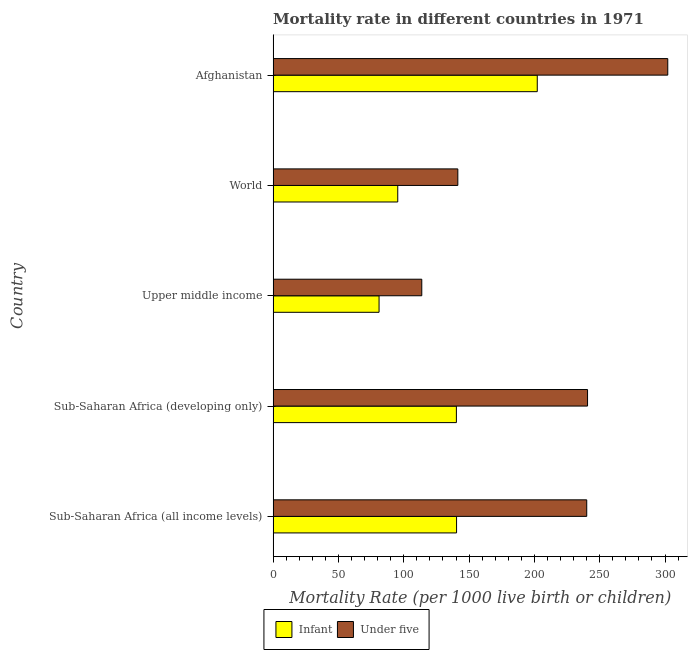How many different coloured bars are there?
Your answer should be very brief. 2. Are the number of bars per tick equal to the number of legend labels?
Your response must be concise. Yes. Are the number of bars on each tick of the Y-axis equal?
Your answer should be compact. Yes. How many bars are there on the 3rd tick from the top?
Keep it short and to the point. 2. How many bars are there on the 1st tick from the bottom?
Offer a terse response. 2. What is the label of the 3rd group of bars from the top?
Offer a terse response. Upper middle income. In how many cases, is the number of bars for a given country not equal to the number of legend labels?
Ensure brevity in your answer.  0. What is the infant mortality rate in World?
Your response must be concise. 95.4. Across all countries, what is the maximum under-5 mortality rate?
Keep it short and to the point. 302.1. Across all countries, what is the minimum infant mortality rate?
Provide a short and direct response. 81.1. In which country was the infant mortality rate maximum?
Your answer should be very brief. Afghanistan. In which country was the under-5 mortality rate minimum?
Your answer should be very brief. Upper middle income. What is the total under-5 mortality rate in the graph?
Provide a short and direct response. 1038.08. What is the difference between the infant mortality rate in Sub-Saharan Africa (developing only) and that in Upper middle income?
Offer a very short reply. 59.2. What is the difference between the under-5 mortality rate in Sub-Saharan Africa (all income levels) and the infant mortality rate in Sub-Saharan Africa (developing only)?
Ensure brevity in your answer.  99.78. What is the average under-5 mortality rate per country?
Provide a short and direct response. 207.62. In how many countries, is the under-5 mortality rate greater than 280 ?
Provide a succinct answer. 1. What is the ratio of the infant mortality rate in Sub-Saharan Africa (developing only) to that in World?
Your answer should be compact. 1.47. Is the under-5 mortality rate in Sub-Saharan Africa (all income levels) less than that in World?
Provide a short and direct response. No. Is the difference between the infant mortality rate in Sub-Saharan Africa (all income levels) and Sub-Saharan Africa (developing only) greater than the difference between the under-5 mortality rate in Sub-Saharan Africa (all income levels) and Sub-Saharan Africa (developing only)?
Ensure brevity in your answer.  Yes. What is the difference between the highest and the second highest infant mortality rate?
Give a very brief answer. 61.78. What is the difference between the highest and the lowest infant mortality rate?
Keep it short and to the point. 121.1. In how many countries, is the under-5 mortality rate greater than the average under-5 mortality rate taken over all countries?
Ensure brevity in your answer.  3. What does the 2nd bar from the top in Upper middle income represents?
Offer a terse response. Infant. What does the 1st bar from the bottom in Sub-Saharan Africa (developing only) represents?
Offer a very short reply. Infant. Are the values on the major ticks of X-axis written in scientific E-notation?
Provide a succinct answer. No. Does the graph contain any zero values?
Provide a succinct answer. No. How many legend labels are there?
Your answer should be very brief. 2. How are the legend labels stacked?
Make the answer very short. Horizontal. What is the title of the graph?
Ensure brevity in your answer.  Mortality rate in different countries in 1971. What is the label or title of the X-axis?
Keep it short and to the point. Mortality Rate (per 1000 live birth or children). What is the label or title of the Y-axis?
Provide a short and direct response. Country. What is the Mortality Rate (per 1000 live birth or children) of Infant in Sub-Saharan Africa (all income levels)?
Make the answer very short. 140.42. What is the Mortality Rate (per 1000 live birth or children) in Under five in Sub-Saharan Africa (all income levels)?
Give a very brief answer. 240.08. What is the Mortality Rate (per 1000 live birth or children) in Infant in Sub-Saharan Africa (developing only)?
Keep it short and to the point. 140.3. What is the Mortality Rate (per 1000 live birth or children) in Under five in Sub-Saharan Africa (developing only)?
Your answer should be compact. 240.7. What is the Mortality Rate (per 1000 live birth or children) of Infant in Upper middle income?
Make the answer very short. 81.1. What is the Mortality Rate (per 1000 live birth or children) of Under five in Upper middle income?
Your response must be concise. 113.8. What is the Mortality Rate (per 1000 live birth or children) of Infant in World?
Ensure brevity in your answer.  95.4. What is the Mortality Rate (per 1000 live birth or children) in Under five in World?
Offer a terse response. 141.4. What is the Mortality Rate (per 1000 live birth or children) in Infant in Afghanistan?
Your response must be concise. 202.2. What is the Mortality Rate (per 1000 live birth or children) in Under five in Afghanistan?
Your response must be concise. 302.1. Across all countries, what is the maximum Mortality Rate (per 1000 live birth or children) of Infant?
Offer a terse response. 202.2. Across all countries, what is the maximum Mortality Rate (per 1000 live birth or children) in Under five?
Your answer should be compact. 302.1. Across all countries, what is the minimum Mortality Rate (per 1000 live birth or children) in Infant?
Offer a very short reply. 81.1. Across all countries, what is the minimum Mortality Rate (per 1000 live birth or children) in Under five?
Offer a very short reply. 113.8. What is the total Mortality Rate (per 1000 live birth or children) in Infant in the graph?
Give a very brief answer. 659.42. What is the total Mortality Rate (per 1000 live birth or children) in Under five in the graph?
Your response must be concise. 1038.08. What is the difference between the Mortality Rate (per 1000 live birth or children) of Infant in Sub-Saharan Africa (all income levels) and that in Sub-Saharan Africa (developing only)?
Make the answer very short. 0.12. What is the difference between the Mortality Rate (per 1000 live birth or children) in Under five in Sub-Saharan Africa (all income levels) and that in Sub-Saharan Africa (developing only)?
Offer a very short reply. -0.62. What is the difference between the Mortality Rate (per 1000 live birth or children) of Infant in Sub-Saharan Africa (all income levels) and that in Upper middle income?
Provide a succinct answer. 59.32. What is the difference between the Mortality Rate (per 1000 live birth or children) in Under five in Sub-Saharan Africa (all income levels) and that in Upper middle income?
Provide a short and direct response. 126.28. What is the difference between the Mortality Rate (per 1000 live birth or children) of Infant in Sub-Saharan Africa (all income levels) and that in World?
Give a very brief answer. 45.02. What is the difference between the Mortality Rate (per 1000 live birth or children) in Under five in Sub-Saharan Africa (all income levels) and that in World?
Offer a terse response. 98.68. What is the difference between the Mortality Rate (per 1000 live birth or children) of Infant in Sub-Saharan Africa (all income levels) and that in Afghanistan?
Give a very brief answer. -61.78. What is the difference between the Mortality Rate (per 1000 live birth or children) of Under five in Sub-Saharan Africa (all income levels) and that in Afghanistan?
Give a very brief answer. -62.02. What is the difference between the Mortality Rate (per 1000 live birth or children) of Infant in Sub-Saharan Africa (developing only) and that in Upper middle income?
Keep it short and to the point. 59.2. What is the difference between the Mortality Rate (per 1000 live birth or children) in Under five in Sub-Saharan Africa (developing only) and that in Upper middle income?
Keep it short and to the point. 126.9. What is the difference between the Mortality Rate (per 1000 live birth or children) of Infant in Sub-Saharan Africa (developing only) and that in World?
Your response must be concise. 44.9. What is the difference between the Mortality Rate (per 1000 live birth or children) of Under five in Sub-Saharan Africa (developing only) and that in World?
Offer a terse response. 99.3. What is the difference between the Mortality Rate (per 1000 live birth or children) of Infant in Sub-Saharan Africa (developing only) and that in Afghanistan?
Offer a terse response. -61.9. What is the difference between the Mortality Rate (per 1000 live birth or children) of Under five in Sub-Saharan Africa (developing only) and that in Afghanistan?
Your answer should be compact. -61.4. What is the difference between the Mortality Rate (per 1000 live birth or children) in Infant in Upper middle income and that in World?
Offer a very short reply. -14.3. What is the difference between the Mortality Rate (per 1000 live birth or children) of Under five in Upper middle income and that in World?
Offer a terse response. -27.6. What is the difference between the Mortality Rate (per 1000 live birth or children) in Infant in Upper middle income and that in Afghanistan?
Your answer should be compact. -121.1. What is the difference between the Mortality Rate (per 1000 live birth or children) of Under five in Upper middle income and that in Afghanistan?
Your answer should be compact. -188.3. What is the difference between the Mortality Rate (per 1000 live birth or children) in Infant in World and that in Afghanistan?
Keep it short and to the point. -106.8. What is the difference between the Mortality Rate (per 1000 live birth or children) of Under five in World and that in Afghanistan?
Ensure brevity in your answer.  -160.7. What is the difference between the Mortality Rate (per 1000 live birth or children) in Infant in Sub-Saharan Africa (all income levels) and the Mortality Rate (per 1000 live birth or children) in Under five in Sub-Saharan Africa (developing only)?
Make the answer very short. -100.28. What is the difference between the Mortality Rate (per 1000 live birth or children) of Infant in Sub-Saharan Africa (all income levels) and the Mortality Rate (per 1000 live birth or children) of Under five in Upper middle income?
Provide a succinct answer. 26.62. What is the difference between the Mortality Rate (per 1000 live birth or children) in Infant in Sub-Saharan Africa (all income levels) and the Mortality Rate (per 1000 live birth or children) in Under five in World?
Give a very brief answer. -0.98. What is the difference between the Mortality Rate (per 1000 live birth or children) in Infant in Sub-Saharan Africa (all income levels) and the Mortality Rate (per 1000 live birth or children) in Under five in Afghanistan?
Keep it short and to the point. -161.68. What is the difference between the Mortality Rate (per 1000 live birth or children) of Infant in Sub-Saharan Africa (developing only) and the Mortality Rate (per 1000 live birth or children) of Under five in Upper middle income?
Your answer should be very brief. 26.5. What is the difference between the Mortality Rate (per 1000 live birth or children) in Infant in Sub-Saharan Africa (developing only) and the Mortality Rate (per 1000 live birth or children) in Under five in World?
Make the answer very short. -1.1. What is the difference between the Mortality Rate (per 1000 live birth or children) in Infant in Sub-Saharan Africa (developing only) and the Mortality Rate (per 1000 live birth or children) in Under five in Afghanistan?
Offer a terse response. -161.8. What is the difference between the Mortality Rate (per 1000 live birth or children) in Infant in Upper middle income and the Mortality Rate (per 1000 live birth or children) in Under five in World?
Your answer should be compact. -60.3. What is the difference between the Mortality Rate (per 1000 live birth or children) of Infant in Upper middle income and the Mortality Rate (per 1000 live birth or children) of Under five in Afghanistan?
Your answer should be compact. -221. What is the difference between the Mortality Rate (per 1000 live birth or children) of Infant in World and the Mortality Rate (per 1000 live birth or children) of Under five in Afghanistan?
Provide a short and direct response. -206.7. What is the average Mortality Rate (per 1000 live birth or children) of Infant per country?
Provide a short and direct response. 131.88. What is the average Mortality Rate (per 1000 live birth or children) in Under five per country?
Offer a terse response. 207.62. What is the difference between the Mortality Rate (per 1000 live birth or children) of Infant and Mortality Rate (per 1000 live birth or children) of Under five in Sub-Saharan Africa (all income levels)?
Offer a very short reply. -99.66. What is the difference between the Mortality Rate (per 1000 live birth or children) in Infant and Mortality Rate (per 1000 live birth or children) in Under five in Sub-Saharan Africa (developing only)?
Your answer should be very brief. -100.4. What is the difference between the Mortality Rate (per 1000 live birth or children) in Infant and Mortality Rate (per 1000 live birth or children) in Under five in Upper middle income?
Ensure brevity in your answer.  -32.7. What is the difference between the Mortality Rate (per 1000 live birth or children) of Infant and Mortality Rate (per 1000 live birth or children) of Under five in World?
Provide a succinct answer. -46. What is the difference between the Mortality Rate (per 1000 live birth or children) in Infant and Mortality Rate (per 1000 live birth or children) in Under five in Afghanistan?
Offer a terse response. -99.9. What is the ratio of the Mortality Rate (per 1000 live birth or children) in Infant in Sub-Saharan Africa (all income levels) to that in Upper middle income?
Your answer should be compact. 1.73. What is the ratio of the Mortality Rate (per 1000 live birth or children) in Under five in Sub-Saharan Africa (all income levels) to that in Upper middle income?
Ensure brevity in your answer.  2.11. What is the ratio of the Mortality Rate (per 1000 live birth or children) in Infant in Sub-Saharan Africa (all income levels) to that in World?
Offer a very short reply. 1.47. What is the ratio of the Mortality Rate (per 1000 live birth or children) in Under five in Sub-Saharan Africa (all income levels) to that in World?
Your response must be concise. 1.7. What is the ratio of the Mortality Rate (per 1000 live birth or children) of Infant in Sub-Saharan Africa (all income levels) to that in Afghanistan?
Your response must be concise. 0.69. What is the ratio of the Mortality Rate (per 1000 live birth or children) in Under five in Sub-Saharan Africa (all income levels) to that in Afghanistan?
Your answer should be very brief. 0.79. What is the ratio of the Mortality Rate (per 1000 live birth or children) of Infant in Sub-Saharan Africa (developing only) to that in Upper middle income?
Ensure brevity in your answer.  1.73. What is the ratio of the Mortality Rate (per 1000 live birth or children) of Under five in Sub-Saharan Africa (developing only) to that in Upper middle income?
Keep it short and to the point. 2.12. What is the ratio of the Mortality Rate (per 1000 live birth or children) in Infant in Sub-Saharan Africa (developing only) to that in World?
Your answer should be very brief. 1.47. What is the ratio of the Mortality Rate (per 1000 live birth or children) of Under five in Sub-Saharan Africa (developing only) to that in World?
Provide a short and direct response. 1.7. What is the ratio of the Mortality Rate (per 1000 live birth or children) in Infant in Sub-Saharan Africa (developing only) to that in Afghanistan?
Offer a very short reply. 0.69. What is the ratio of the Mortality Rate (per 1000 live birth or children) in Under five in Sub-Saharan Africa (developing only) to that in Afghanistan?
Make the answer very short. 0.8. What is the ratio of the Mortality Rate (per 1000 live birth or children) of Infant in Upper middle income to that in World?
Your answer should be compact. 0.85. What is the ratio of the Mortality Rate (per 1000 live birth or children) of Under five in Upper middle income to that in World?
Your response must be concise. 0.8. What is the ratio of the Mortality Rate (per 1000 live birth or children) in Infant in Upper middle income to that in Afghanistan?
Keep it short and to the point. 0.4. What is the ratio of the Mortality Rate (per 1000 live birth or children) in Under five in Upper middle income to that in Afghanistan?
Your answer should be compact. 0.38. What is the ratio of the Mortality Rate (per 1000 live birth or children) of Infant in World to that in Afghanistan?
Keep it short and to the point. 0.47. What is the ratio of the Mortality Rate (per 1000 live birth or children) in Under five in World to that in Afghanistan?
Provide a short and direct response. 0.47. What is the difference between the highest and the second highest Mortality Rate (per 1000 live birth or children) of Infant?
Give a very brief answer. 61.78. What is the difference between the highest and the second highest Mortality Rate (per 1000 live birth or children) of Under five?
Give a very brief answer. 61.4. What is the difference between the highest and the lowest Mortality Rate (per 1000 live birth or children) of Infant?
Provide a short and direct response. 121.1. What is the difference between the highest and the lowest Mortality Rate (per 1000 live birth or children) in Under five?
Your answer should be very brief. 188.3. 